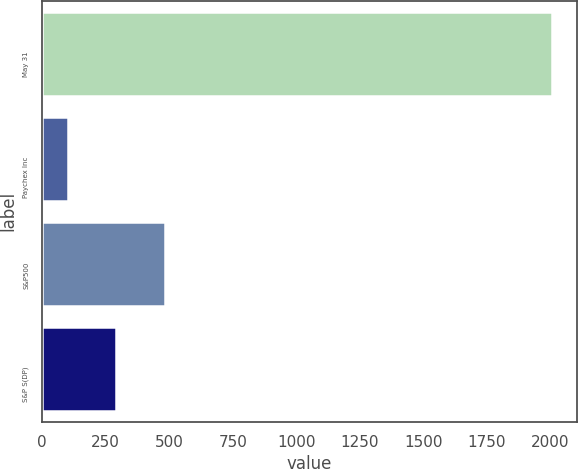Convert chart. <chart><loc_0><loc_0><loc_500><loc_500><bar_chart><fcel>May 31<fcel>Paychex Inc<fcel>S&P500<fcel>S&P S(DP)<nl><fcel>2006<fcel>101.11<fcel>482.09<fcel>291.6<nl></chart> 